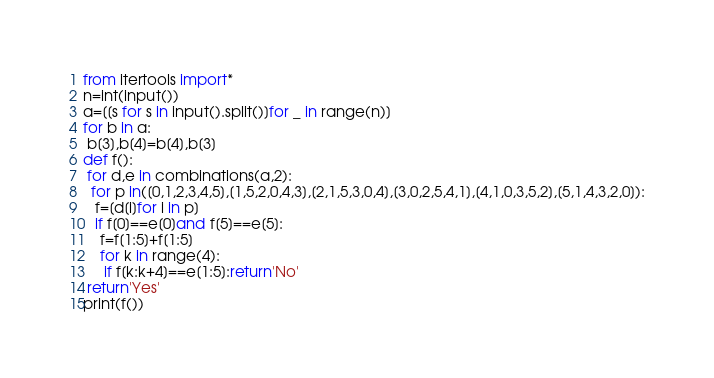<code> <loc_0><loc_0><loc_500><loc_500><_Python_>from itertools import*
n=int(input())
a=[[s for s in input().split()]for _ in range(n)]
for b in a:
 b[3],b[4]=b[4],b[3]
def f():
 for d,e in combinations(a,2):
  for p in([0,1,2,3,4,5],[1,5,2,0,4,3],[2,1,5,3,0,4],[3,0,2,5,4,1],[4,1,0,3,5,2],[5,1,4,3,2,0]):
   f=[d[i]for i in p]
   if f[0]==e[0]and f[5]==e[5]:
    f=f[1:5]+f[1:5]
    for k in range(4):
     if f[k:k+4]==e[1:5]:return'No'
 return'Yes'
print(f())
</code> 